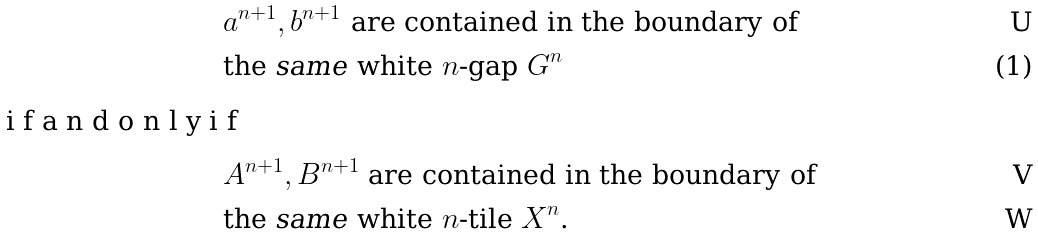Convert formula to latex. <formula><loc_0><loc_0><loc_500><loc_500>& \text {$a^{n+1},b^{n+1}$ are contained in the boundary of } \\ & \text {the     \emph{same} white $n$-gap } G ^ { n } \intertext { i f a n d o n l y i f } & A ^ { n + 1 } , B ^ { n + 1 } \text { are contained in the boundary of} \\ & \text {the \emph{same} white $n$-tile $X^{n}$.}</formula> 